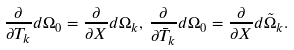Convert formula to latex. <formula><loc_0><loc_0><loc_500><loc_500>\frac { \partial } { \partial T _ { k } } d \Omega _ { 0 } = \frac { \partial } { \partial X } d \Omega _ { k } , \, \frac { \partial } { \partial \bar { T } _ { k } } d \Omega _ { 0 } = \frac { \partial } { \partial X } d \tilde { \Omega } _ { k } .</formula> 